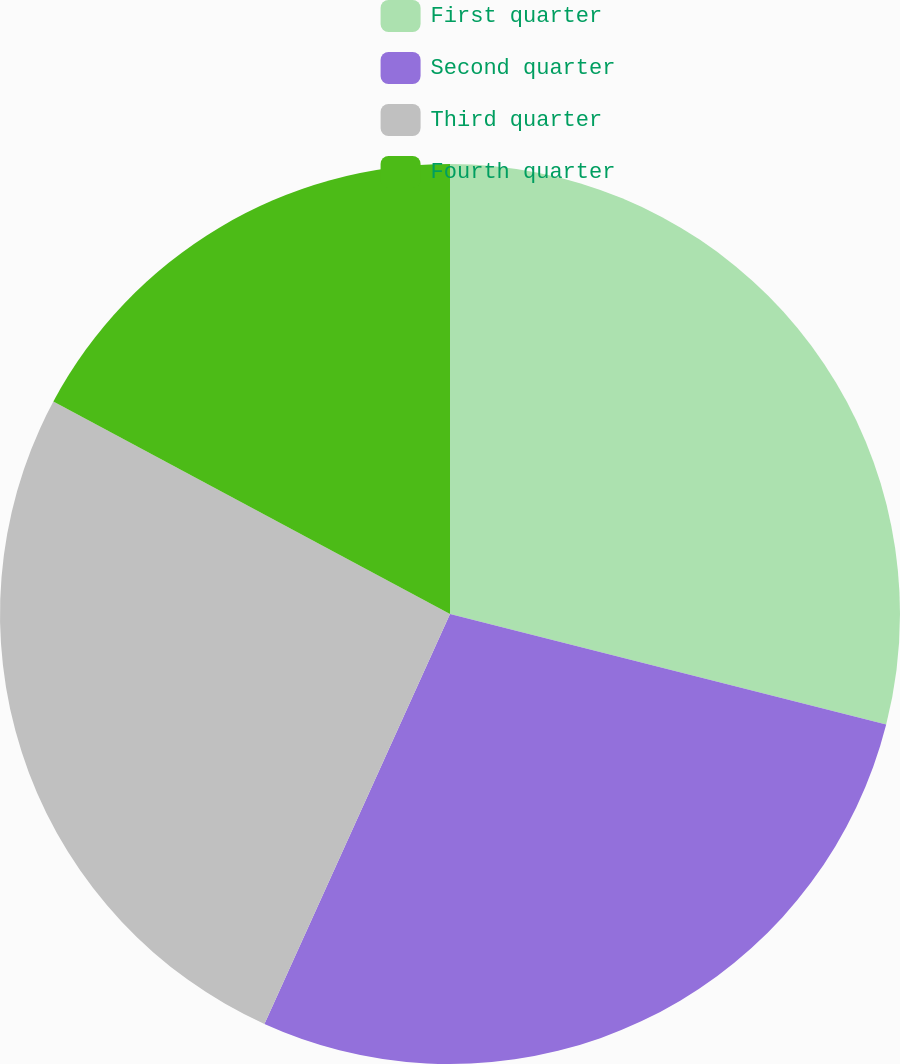Convert chart to OTSL. <chart><loc_0><loc_0><loc_500><loc_500><pie_chart><fcel>First quarter<fcel>Second quarter<fcel>Third quarter<fcel>Fourth quarter<nl><fcel>28.95%<fcel>27.81%<fcel>26.06%<fcel>17.17%<nl></chart> 